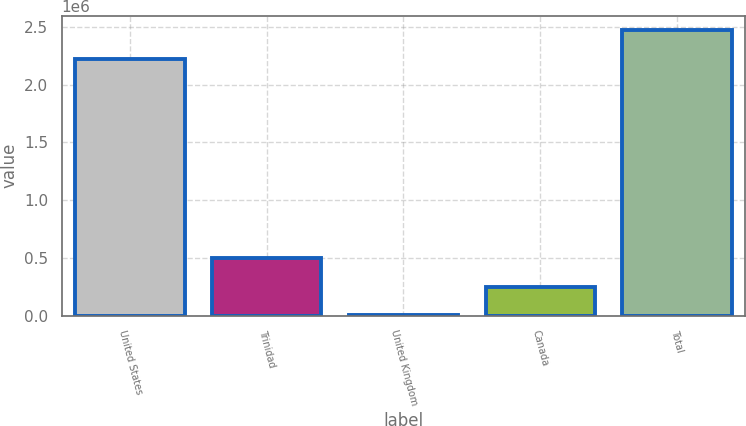<chart> <loc_0><loc_0><loc_500><loc_500><bar_chart><fcel>United States<fcel>Trinidad<fcel>United Kingdom<fcel>Canada<fcel>Total<nl><fcel>2.22509e+06<fcel>497201<fcel>5603<fcel>251402<fcel>2.47089e+06<nl></chart> 